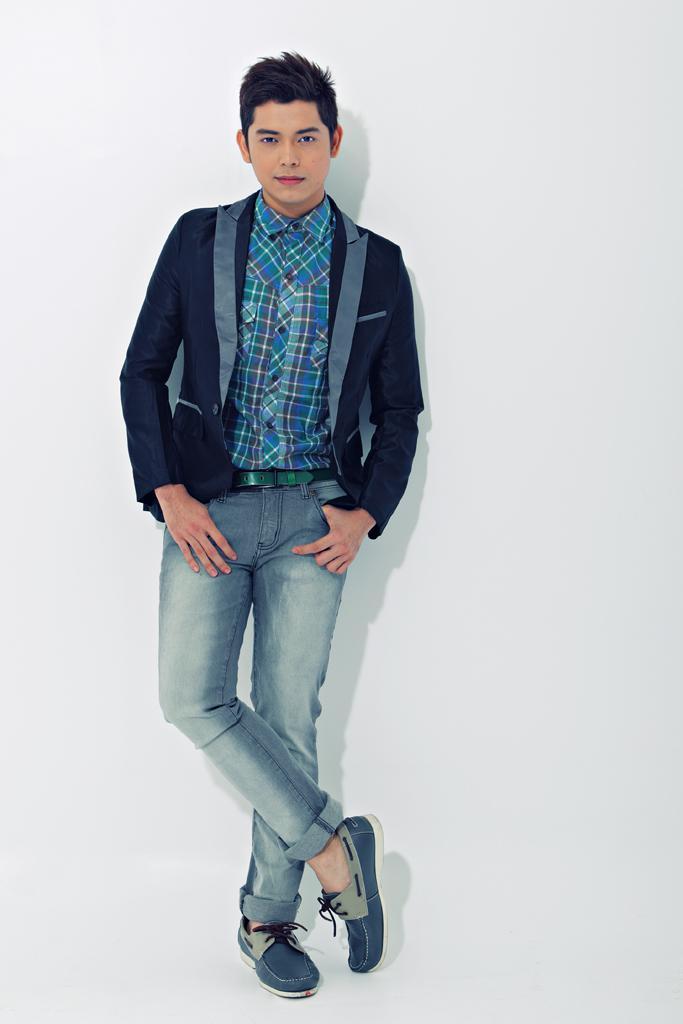How would you summarize this image in a sentence or two? In this image I can see a person standing in the center of the image and posing for the picture. 